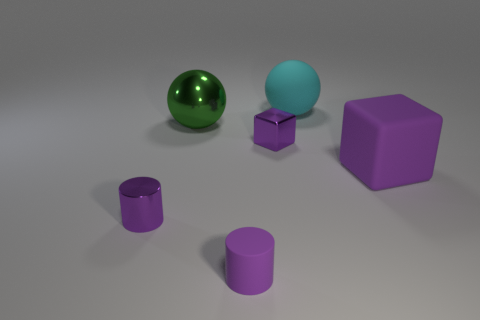Is there a big green object that has the same material as the big purple cube?
Give a very brief answer. No. There is a metallic cylinder that is the same color as the tiny rubber thing; what is its size?
Offer a terse response. Small. Is the number of large brown matte cubes less than the number of purple rubber blocks?
Offer a very short reply. Yes. There is a tiny cylinder left of the large green ball; does it have the same color as the tiny cube?
Your answer should be compact. Yes. What material is the big sphere that is on the right side of the green metallic object that is behind the cube on the right side of the cyan sphere made of?
Your response must be concise. Rubber. Are there any tiny metal cylinders that have the same color as the large metallic ball?
Your response must be concise. No. Is the number of big purple matte things that are in front of the purple matte cylinder less than the number of green rubber cylinders?
Make the answer very short. No. Is the size of the purple thing that is to the right of the cyan matte sphere the same as the small purple cube?
Keep it short and to the point. No. What number of objects are both in front of the large cyan matte thing and behind the purple matte cube?
Keep it short and to the point. 2. There is a block right of the purple cube left of the large matte cube; what is its size?
Ensure brevity in your answer.  Large. 